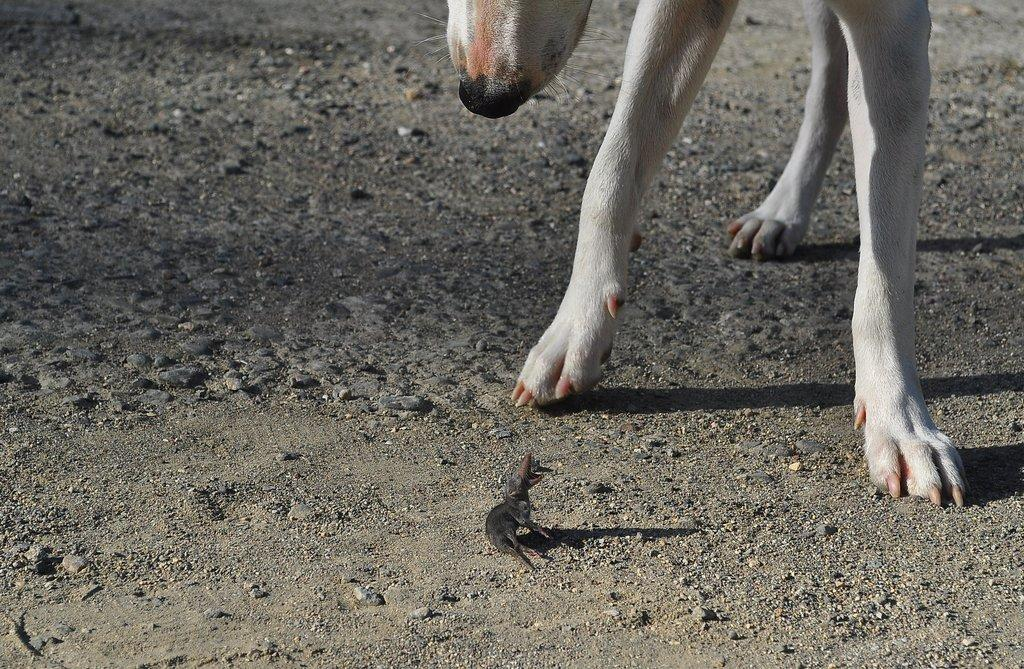What type of animal is on the ground in the foreground of the image? The type of animal on the ground in the foreground of the image is not specified in the facts provided. Can you describe the dog visible at the top of the image? The facts provided only mention the presence of a dog at the top of the image, without any details about its appearance or characteristics. How many sisters are interacting with the dog in the image? There is no mention of sisters or any interaction with the dog in the image, as the facts provided only mention the presence of an animal on the ground and a dog at the top of the image. 